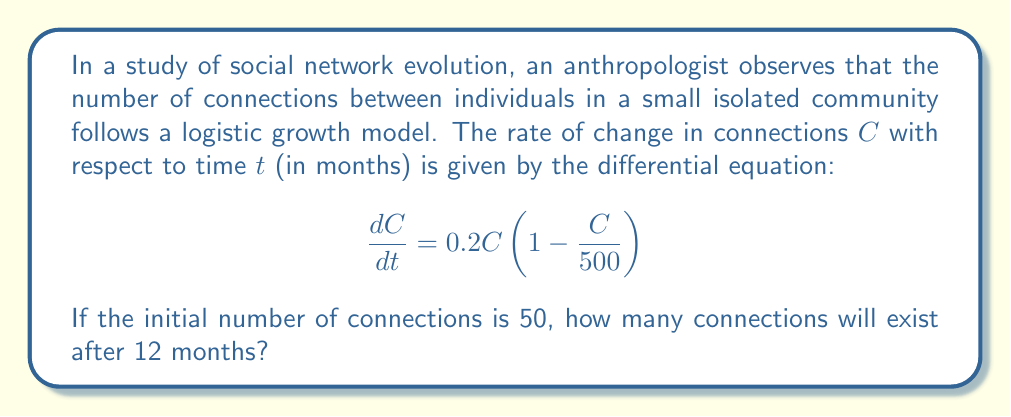Help me with this question. To solve this problem, we need to use the logistic growth model and its solution. The steps are as follows:

1) The general form of the logistic differential equation is:
   $$\frac{dP}{dt} = rP\left(1 - \frac{P}{K}\right)$$
   where $r$ is the growth rate and $K$ is the carrying capacity.

2) In our case, $r = 0.2$ and $K = 500$.

3) The solution to the logistic differential equation is:
   $$P(t) = \frac{K}{1 + \left(\frac{K}{P_0} - 1\right)e^{-rt}}$$
   where $P_0$ is the initial population (or in this case, initial number of connections).

4) Substituting our values:
   $$C(t) = \frac{500}{1 + \left(\frac{500}{50} - 1\right)e^{-0.2t}}$$

5) Simplify:
   $$C(t) = \frac{500}{1 + 9e^{-0.2t}}$$

6) We want to find $C(12)$, so let's substitute $t = 12$:
   $$C(12) = \frac{500}{1 + 9e^{-0.2(12)}}$$

7) Calculate:
   $$C(12) = \frac{500}{1 + 9e^{-2.4}} \approx 304.45$$

8) Since we're dealing with connections between people, we need to round to the nearest whole number.
Answer: 304 connections 